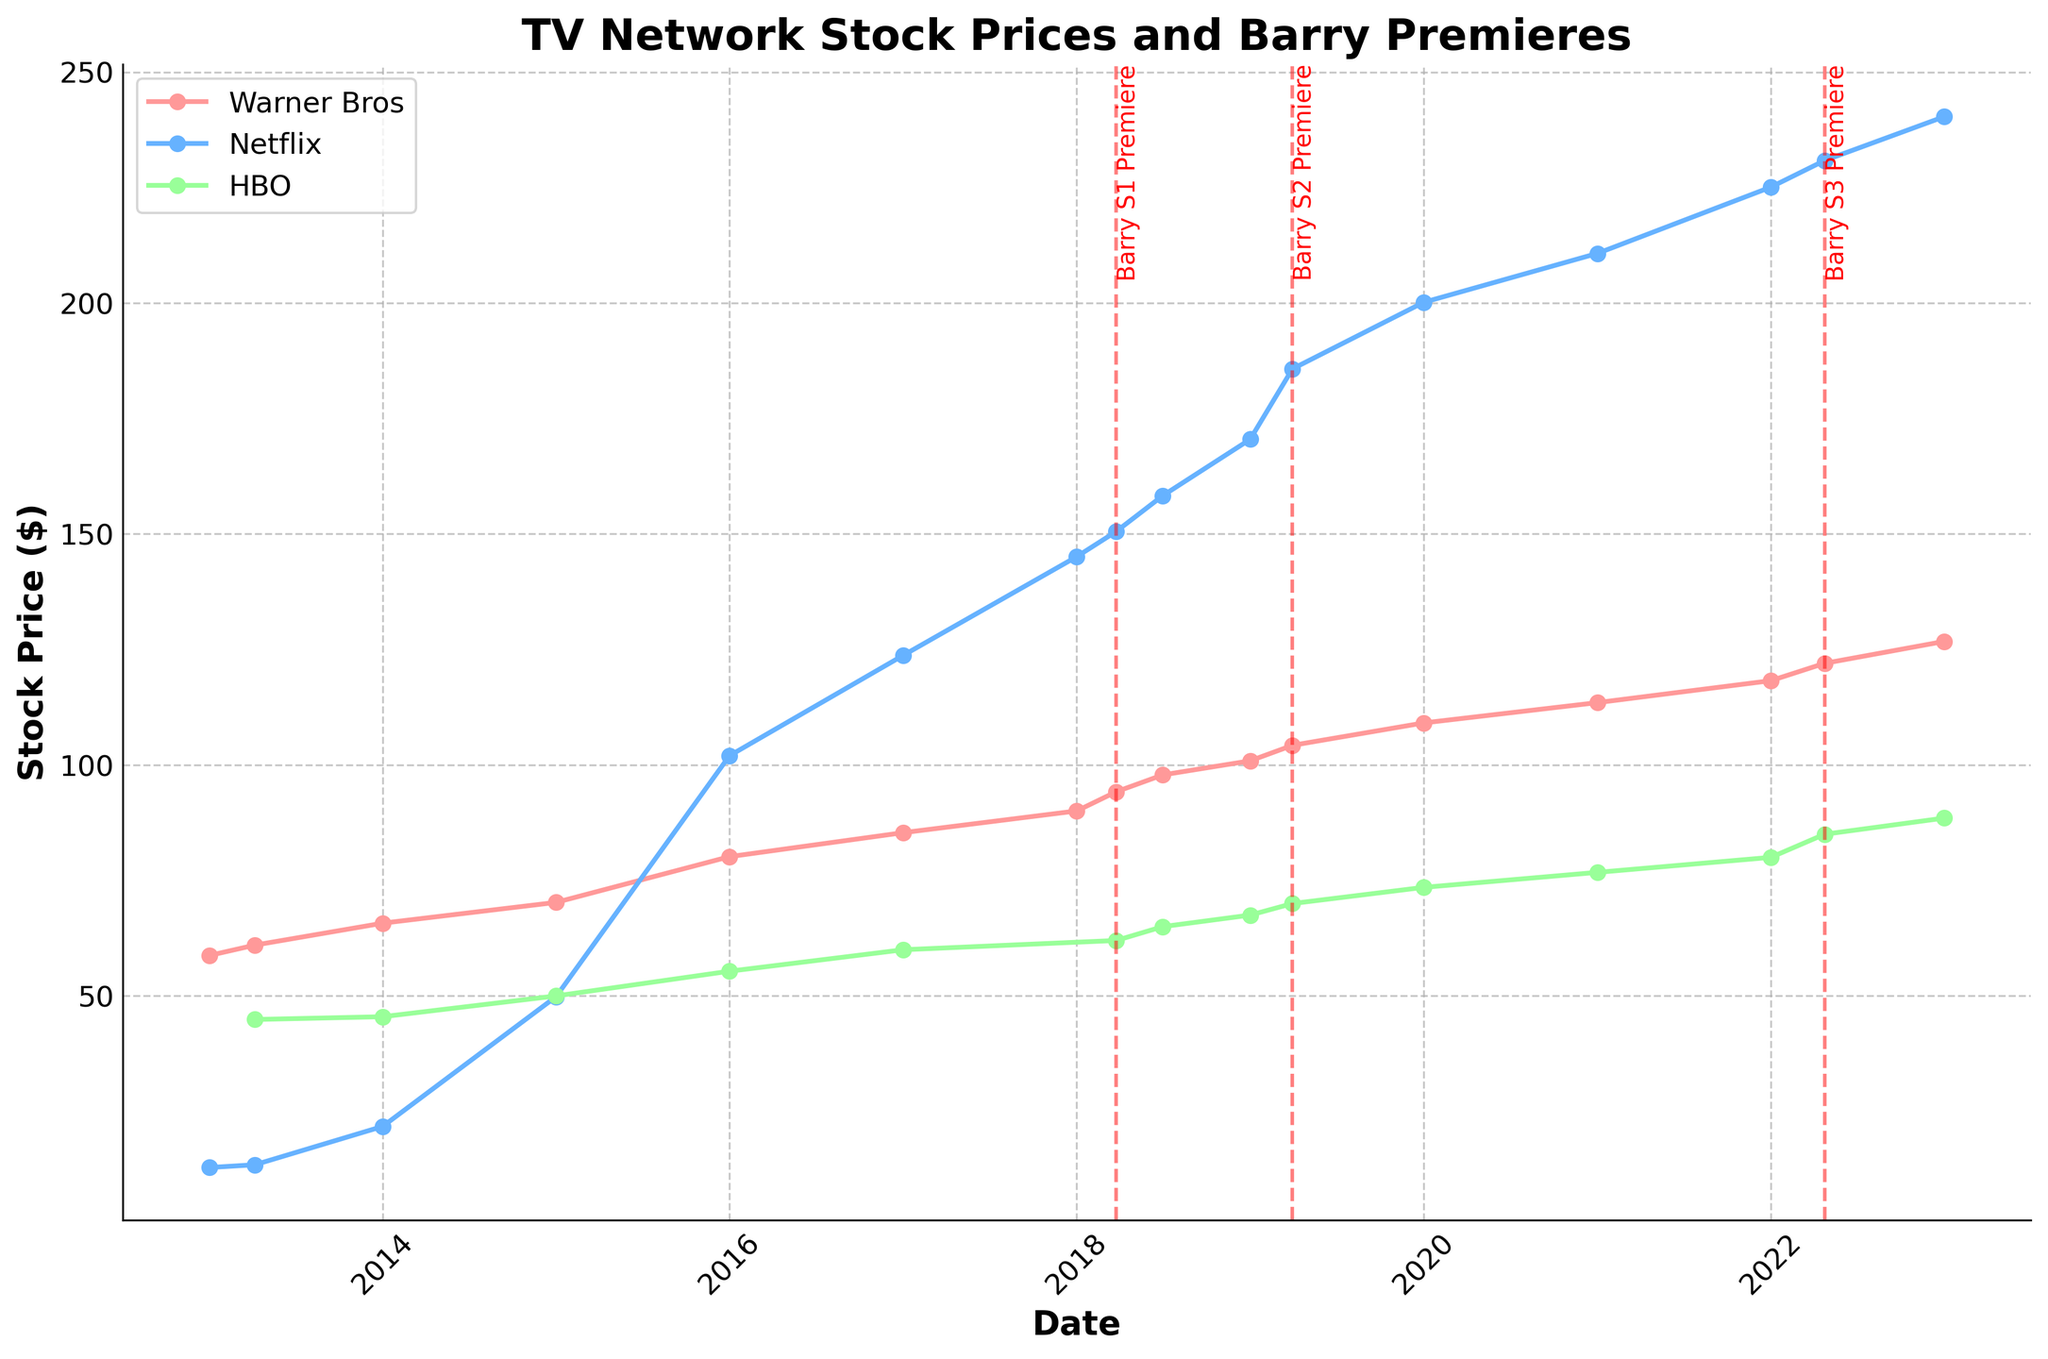What is the title of the plot? The title of the plot is located at the top of the figure, usually centered and in a larger, bold font, which summarizes the main topic of the visualization.
Answer: TV Network Stock Prices and Barry Premieres Which network had the highest stock price on January 1, 2023? To find the highest stock price for each network, look at the stock prices on the date January 1, 2023, for all networks and identify the largest value.
Answer: Netflix How many Barry premieres are marked on the plot? Barry premieres are represented by vertical dashed lines and labeled with dates. Count the number of these lines and labels on the plot.
Answer: 3 What was HBO's stock price just before the premiere of Barry Season 1? Identify the date of the Barry Season 1 premiere, then locate the HBO stock price closest to but before this date.
Answer: 60.00 How did HBO's stock price change immediately after the Barry Season 1 premiere? Locate the stock price for HBO on the date just before and after the Barry Season 1 premiere date and calculate the difference. (62.00 - 60.00 = 2.00)
Answer: Increased by 2.00 Which network experienced the largest stock price increase after the Barry Season 3 premiere? Compare the stock prices of all networks before and after the Barry Season 3 premiere. Identify the network with the greatest positive difference.
Answer: HBO Compare the trend of Netflix's stock price with that of Warner Bros. between 2013 and 2023. Which network had a steeper increase? Examine the start and end stock prices of Netflix and Warner Bros. from 2013 to 2023, calculate the change for both networks, and compare. (Netflix: 240.35 - 12.85 = 227.5, WB: 126.75 - 58.75 = 68.00)
Answer: Netflix What was the combined stock price of all three networks on January 1, 2021? Find and add the stock prices of HBO, Warner Bros., and Netflix on January 1, 2021. (76.75 + 113.50 + 210.75 = 401.00)
Answer: 401.00 Which network had the most consistent stock price increase over the decade? Visual inspection of the plot for consistent year-on-year increases without major fluctuations indicates the most consistent network.
Answer: Netflix 